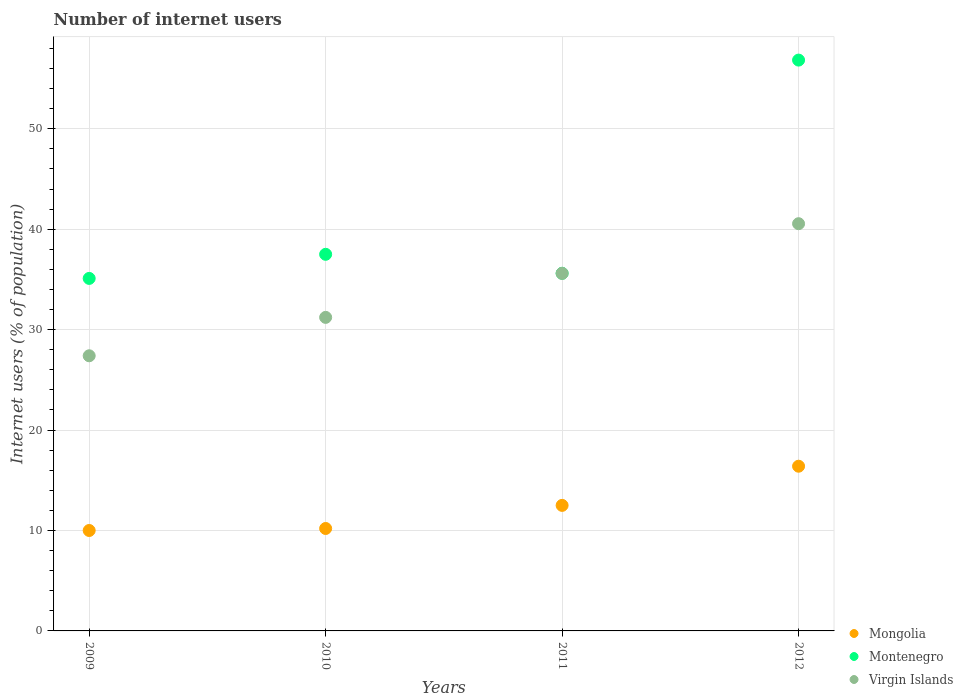How many different coloured dotlines are there?
Your response must be concise. 3. Is the number of dotlines equal to the number of legend labels?
Give a very brief answer. Yes. Across all years, what is the minimum number of internet users in Virgin Islands?
Offer a very short reply. 27.4. In which year was the number of internet users in Mongolia maximum?
Offer a very short reply. 2012. What is the total number of internet users in Montenegro in the graph?
Your answer should be very brief. 165.05. What is the difference between the number of internet users in Mongolia in 2009 and that in 2012?
Offer a very short reply. -6.4. What is the difference between the number of internet users in Virgin Islands in 2009 and the number of internet users in Montenegro in 2010?
Ensure brevity in your answer.  -10.1. What is the average number of internet users in Virgin Islands per year?
Your answer should be compact. 33.69. In the year 2012, what is the difference between the number of internet users in Virgin Islands and number of internet users in Montenegro?
Give a very brief answer. -16.29. In how many years, is the number of internet users in Montenegro greater than 8 %?
Provide a succinct answer. 4. What is the ratio of the number of internet users in Montenegro in 2009 to that in 2010?
Keep it short and to the point. 0.94. Is the number of internet users in Virgin Islands in 2010 less than that in 2012?
Your answer should be very brief. Yes. What is the difference between the highest and the second highest number of internet users in Montenegro?
Offer a terse response. 19.34. What is the difference between the highest and the lowest number of internet users in Virgin Islands?
Your response must be concise. 13.15. In how many years, is the number of internet users in Mongolia greater than the average number of internet users in Mongolia taken over all years?
Give a very brief answer. 2. Is the sum of the number of internet users in Virgin Islands in 2009 and 2010 greater than the maximum number of internet users in Mongolia across all years?
Keep it short and to the point. Yes. Is the number of internet users in Virgin Islands strictly greater than the number of internet users in Mongolia over the years?
Keep it short and to the point. Yes. Is the number of internet users in Mongolia strictly less than the number of internet users in Virgin Islands over the years?
Your answer should be very brief. Yes. What is the difference between two consecutive major ticks on the Y-axis?
Keep it short and to the point. 10. Are the values on the major ticks of Y-axis written in scientific E-notation?
Ensure brevity in your answer.  No. Does the graph contain any zero values?
Make the answer very short. No. Where does the legend appear in the graph?
Your answer should be compact. Bottom right. What is the title of the graph?
Ensure brevity in your answer.  Number of internet users. What is the label or title of the Y-axis?
Offer a very short reply. Internet users (% of population). What is the Internet users (% of population) of Montenegro in 2009?
Offer a very short reply. 35.1. What is the Internet users (% of population) in Virgin Islands in 2009?
Your answer should be very brief. 27.4. What is the Internet users (% of population) of Mongolia in 2010?
Your answer should be compact. 10.2. What is the Internet users (% of population) of Montenegro in 2010?
Provide a succinct answer. 37.5. What is the Internet users (% of population) of Virgin Islands in 2010?
Your answer should be very brief. 31.22. What is the Internet users (% of population) in Mongolia in 2011?
Your answer should be very brief. 12.5. What is the Internet users (% of population) of Montenegro in 2011?
Provide a short and direct response. 35.61. What is the Internet users (% of population) in Virgin Islands in 2011?
Offer a terse response. 35.6. What is the Internet users (% of population) of Mongolia in 2012?
Give a very brief answer. 16.4. What is the Internet users (% of population) of Montenegro in 2012?
Your response must be concise. 56.84. What is the Internet users (% of population) in Virgin Islands in 2012?
Keep it short and to the point. 40.55. Across all years, what is the maximum Internet users (% of population) of Montenegro?
Offer a terse response. 56.84. Across all years, what is the maximum Internet users (% of population) in Virgin Islands?
Ensure brevity in your answer.  40.55. Across all years, what is the minimum Internet users (% of population) of Mongolia?
Keep it short and to the point. 10. Across all years, what is the minimum Internet users (% of population) of Montenegro?
Give a very brief answer. 35.1. Across all years, what is the minimum Internet users (% of population) in Virgin Islands?
Make the answer very short. 27.4. What is the total Internet users (% of population) of Mongolia in the graph?
Provide a short and direct response. 49.1. What is the total Internet users (% of population) of Montenegro in the graph?
Your answer should be very brief. 165.05. What is the total Internet users (% of population) of Virgin Islands in the graph?
Ensure brevity in your answer.  134.76. What is the difference between the Internet users (% of population) of Montenegro in 2009 and that in 2010?
Offer a very short reply. -2.4. What is the difference between the Internet users (% of population) in Virgin Islands in 2009 and that in 2010?
Make the answer very short. -3.82. What is the difference between the Internet users (% of population) of Mongolia in 2009 and that in 2011?
Provide a succinct answer. -2.5. What is the difference between the Internet users (% of population) of Montenegro in 2009 and that in 2011?
Give a very brief answer. -0.51. What is the difference between the Internet users (% of population) of Virgin Islands in 2009 and that in 2011?
Offer a very short reply. -8.2. What is the difference between the Internet users (% of population) in Mongolia in 2009 and that in 2012?
Your answer should be compact. -6.4. What is the difference between the Internet users (% of population) in Montenegro in 2009 and that in 2012?
Offer a terse response. -21.74. What is the difference between the Internet users (% of population) in Virgin Islands in 2009 and that in 2012?
Provide a succinct answer. -13.15. What is the difference between the Internet users (% of population) in Mongolia in 2010 and that in 2011?
Your answer should be compact. -2.3. What is the difference between the Internet users (% of population) in Montenegro in 2010 and that in 2011?
Your answer should be very brief. 1.89. What is the difference between the Internet users (% of population) of Virgin Islands in 2010 and that in 2011?
Offer a terse response. -4.38. What is the difference between the Internet users (% of population) in Mongolia in 2010 and that in 2012?
Provide a succinct answer. -6.2. What is the difference between the Internet users (% of population) of Montenegro in 2010 and that in 2012?
Keep it short and to the point. -19.34. What is the difference between the Internet users (% of population) in Virgin Islands in 2010 and that in 2012?
Keep it short and to the point. -9.33. What is the difference between the Internet users (% of population) of Montenegro in 2011 and that in 2012?
Your answer should be very brief. -21.23. What is the difference between the Internet users (% of population) in Virgin Islands in 2011 and that in 2012?
Provide a succinct answer. -4.95. What is the difference between the Internet users (% of population) in Mongolia in 2009 and the Internet users (% of population) in Montenegro in 2010?
Provide a succinct answer. -27.5. What is the difference between the Internet users (% of population) in Mongolia in 2009 and the Internet users (% of population) in Virgin Islands in 2010?
Offer a very short reply. -21.22. What is the difference between the Internet users (% of population) of Montenegro in 2009 and the Internet users (% of population) of Virgin Islands in 2010?
Make the answer very short. 3.88. What is the difference between the Internet users (% of population) of Mongolia in 2009 and the Internet users (% of population) of Montenegro in 2011?
Your answer should be very brief. -25.61. What is the difference between the Internet users (% of population) of Mongolia in 2009 and the Internet users (% of population) of Virgin Islands in 2011?
Offer a very short reply. -25.6. What is the difference between the Internet users (% of population) of Montenegro in 2009 and the Internet users (% of population) of Virgin Islands in 2011?
Provide a succinct answer. -0.5. What is the difference between the Internet users (% of population) of Mongolia in 2009 and the Internet users (% of population) of Montenegro in 2012?
Keep it short and to the point. -46.84. What is the difference between the Internet users (% of population) in Mongolia in 2009 and the Internet users (% of population) in Virgin Islands in 2012?
Your answer should be very brief. -30.55. What is the difference between the Internet users (% of population) of Montenegro in 2009 and the Internet users (% of population) of Virgin Islands in 2012?
Offer a terse response. -5.45. What is the difference between the Internet users (% of population) in Mongolia in 2010 and the Internet users (% of population) in Montenegro in 2011?
Keep it short and to the point. -25.41. What is the difference between the Internet users (% of population) in Mongolia in 2010 and the Internet users (% of population) in Virgin Islands in 2011?
Ensure brevity in your answer.  -25.4. What is the difference between the Internet users (% of population) of Mongolia in 2010 and the Internet users (% of population) of Montenegro in 2012?
Keep it short and to the point. -46.64. What is the difference between the Internet users (% of population) of Mongolia in 2010 and the Internet users (% of population) of Virgin Islands in 2012?
Offer a terse response. -30.35. What is the difference between the Internet users (% of population) of Montenegro in 2010 and the Internet users (% of population) of Virgin Islands in 2012?
Your response must be concise. -3.05. What is the difference between the Internet users (% of population) in Mongolia in 2011 and the Internet users (% of population) in Montenegro in 2012?
Provide a succinct answer. -44.34. What is the difference between the Internet users (% of population) in Mongolia in 2011 and the Internet users (% of population) in Virgin Islands in 2012?
Give a very brief answer. -28.05. What is the difference between the Internet users (% of population) in Montenegro in 2011 and the Internet users (% of population) in Virgin Islands in 2012?
Provide a short and direct response. -4.94. What is the average Internet users (% of population) in Mongolia per year?
Offer a terse response. 12.28. What is the average Internet users (% of population) of Montenegro per year?
Make the answer very short. 41.26. What is the average Internet users (% of population) in Virgin Islands per year?
Give a very brief answer. 33.69. In the year 2009, what is the difference between the Internet users (% of population) in Mongolia and Internet users (% of population) in Montenegro?
Provide a short and direct response. -25.1. In the year 2009, what is the difference between the Internet users (% of population) of Mongolia and Internet users (% of population) of Virgin Islands?
Your response must be concise. -17.4. In the year 2009, what is the difference between the Internet users (% of population) in Montenegro and Internet users (% of population) in Virgin Islands?
Offer a terse response. 7.7. In the year 2010, what is the difference between the Internet users (% of population) of Mongolia and Internet users (% of population) of Montenegro?
Make the answer very short. -27.3. In the year 2010, what is the difference between the Internet users (% of population) of Mongolia and Internet users (% of population) of Virgin Islands?
Your answer should be very brief. -21.02. In the year 2010, what is the difference between the Internet users (% of population) in Montenegro and Internet users (% of population) in Virgin Islands?
Make the answer very short. 6.28. In the year 2011, what is the difference between the Internet users (% of population) in Mongolia and Internet users (% of population) in Montenegro?
Provide a short and direct response. -23.11. In the year 2011, what is the difference between the Internet users (% of population) of Mongolia and Internet users (% of population) of Virgin Islands?
Provide a succinct answer. -23.1. In the year 2011, what is the difference between the Internet users (% of population) of Montenegro and Internet users (% of population) of Virgin Islands?
Offer a very short reply. 0.01. In the year 2012, what is the difference between the Internet users (% of population) in Mongolia and Internet users (% of population) in Montenegro?
Your answer should be very brief. -40.44. In the year 2012, what is the difference between the Internet users (% of population) of Mongolia and Internet users (% of population) of Virgin Islands?
Ensure brevity in your answer.  -24.15. In the year 2012, what is the difference between the Internet users (% of population) of Montenegro and Internet users (% of population) of Virgin Islands?
Keep it short and to the point. 16.29. What is the ratio of the Internet users (% of population) of Mongolia in 2009 to that in 2010?
Give a very brief answer. 0.98. What is the ratio of the Internet users (% of population) in Montenegro in 2009 to that in 2010?
Your answer should be very brief. 0.94. What is the ratio of the Internet users (% of population) in Virgin Islands in 2009 to that in 2010?
Provide a succinct answer. 0.88. What is the ratio of the Internet users (% of population) of Mongolia in 2009 to that in 2011?
Ensure brevity in your answer.  0.8. What is the ratio of the Internet users (% of population) of Montenegro in 2009 to that in 2011?
Make the answer very short. 0.99. What is the ratio of the Internet users (% of population) of Virgin Islands in 2009 to that in 2011?
Your response must be concise. 0.77. What is the ratio of the Internet users (% of population) of Mongolia in 2009 to that in 2012?
Your answer should be compact. 0.61. What is the ratio of the Internet users (% of population) of Montenegro in 2009 to that in 2012?
Offer a very short reply. 0.62. What is the ratio of the Internet users (% of population) of Virgin Islands in 2009 to that in 2012?
Make the answer very short. 0.68. What is the ratio of the Internet users (% of population) of Mongolia in 2010 to that in 2011?
Your answer should be very brief. 0.82. What is the ratio of the Internet users (% of population) in Montenegro in 2010 to that in 2011?
Your answer should be very brief. 1.05. What is the ratio of the Internet users (% of population) of Virgin Islands in 2010 to that in 2011?
Offer a very short reply. 0.88. What is the ratio of the Internet users (% of population) in Mongolia in 2010 to that in 2012?
Ensure brevity in your answer.  0.62. What is the ratio of the Internet users (% of population) of Montenegro in 2010 to that in 2012?
Your answer should be very brief. 0.66. What is the ratio of the Internet users (% of population) of Virgin Islands in 2010 to that in 2012?
Your response must be concise. 0.77. What is the ratio of the Internet users (% of population) in Mongolia in 2011 to that in 2012?
Your answer should be very brief. 0.76. What is the ratio of the Internet users (% of population) of Montenegro in 2011 to that in 2012?
Ensure brevity in your answer.  0.63. What is the ratio of the Internet users (% of population) in Virgin Islands in 2011 to that in 2012?
Your response must be concise. 0.88. What is the difference between the highest and the second highest Internet users (% of population) of Montenegro?
Make the answer very short. 19.34. What is the difference between the highest and the second highest Internet users (% of population) in Virgin Islands?
Offer a terse response. 4.95. What is the difference between the highest and the lowest Internet users (% of population) in Montenegro?
Your response must be concise. 21.74. What is the difference between the highest and the lowest Internet users (% of population) in Virgin Islands?
Make the answer very short. 13.15. 